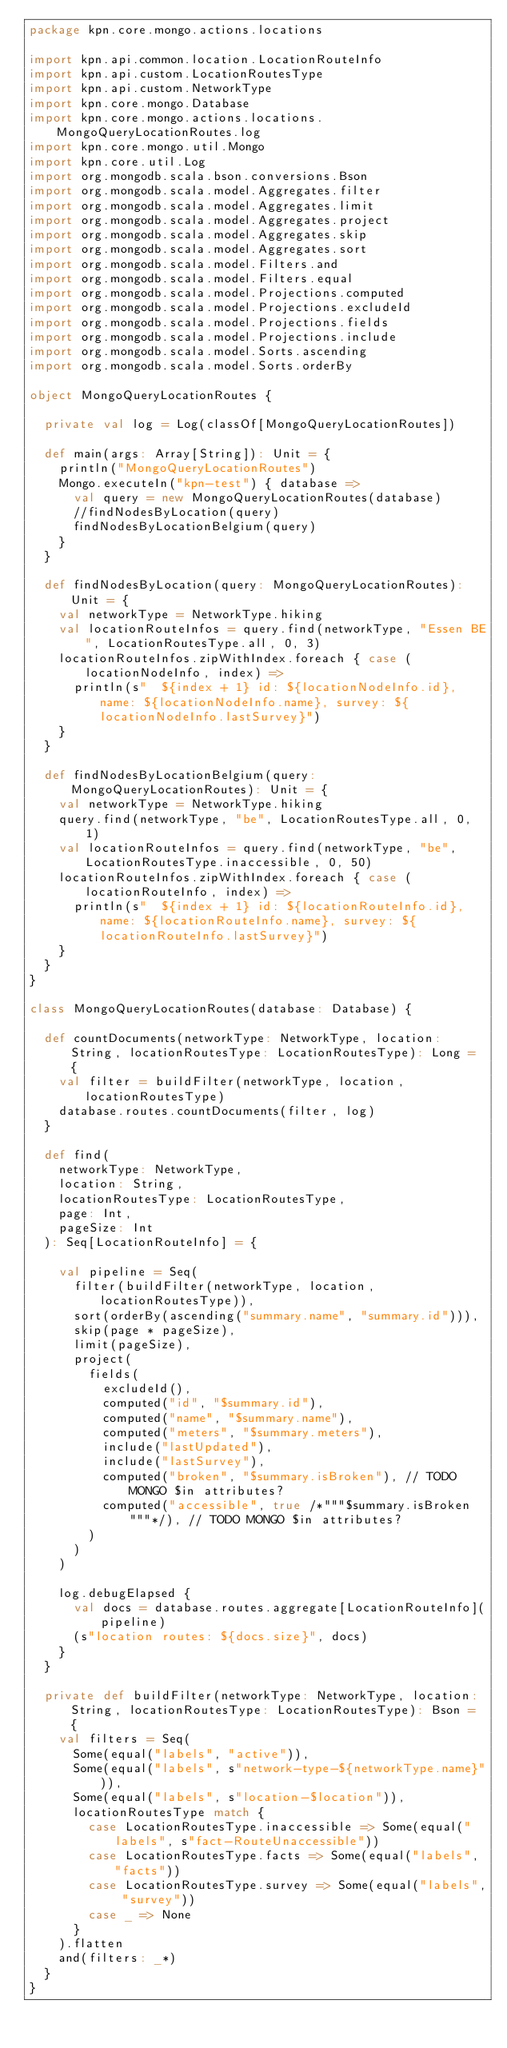Convert code to text. <code><loc_0><loc_0><loc_500><loc_500><_Scala_>package kpn.core.mongo.actions.locations

import kpn.api.common.location.LocationRouteInfo
import kpn.api.custom.LocationRoutesType
import kpn.api.custom.NetworkType
import kpn.core.mongo.Database
import kpn.core.mongo.actions.locations.MongoQueryLocationRoutes.log
import kpn.core.mongo.util.Mongo
import kpn.core.util.Log
import org.mongodb.scala.bson.conversions.Bson
import org.mongodb.scala.model.Aggregates.filter
import org.mongodb.scala.model.Aggregates.limit
import org.mongodb.scala.model.Aggregates.project
import org.mongodb.scala.model.Aggregates.skip
import org.mongodb.scala.model.Aggregates.sort
import org.mongodb.scala.model.Filters.and
import org.mongodb.scala.model.Filters.equal
import org.mongodb.scala.model.Projections.computed
import org.mongodb.scala.model.Projections.excludeId
import org.mongodb.scala.model.Projections.fields
import org.mongodb.scala.model.Projections.include
import org.mongodb.scala.model.Sorts.ascending
import org.mongodb.scala.model.Sorts.orderBy

object MongoQueryLocationRoutes {

  private val log = Log(classOf[MongoQueryLocationRoutes])

  def main(args: Array[String]): Unit = {
    println("MongoQueryLocationRoutes")
    Mongo.executeIn("kpn-test") { database =>
      val query = new MongoQueryLocationRoutes(database)
      //findNodesByLocation(query)
      findNodesByLocationBelgium(query)
    }
  }

  def findNodesByLocation(query: MongoQueryLocationRoutes): Unit = {
    val networkType = NetworkType.hiking
    val locationRouteInfos = query.find(networkType, "Essen BE", LocationRoutesType.all, 0, 3)
    locationRouteInfos.zipWithIndex.foreach { case (locationNodeInfo, index) =>
      println(s"  ${index + 1} id: ${locationNodeInfo.id}, name: ${locationNodeInfo.name}, survey: ${locationNodeInfo.lastSurvey}")
    }
  }

  def findNodesByLocationBelgium(query: MongoQueryLocationRoutes): Unit = {
    val networkType = NetworkType.hiking
    query.find(networkType, "be", LocationRoutesType.all, 0, 1)
    val locationRouteInfos = query.find(networkType, "be", LocationRoutesType.inaccessible, 0, 50)
    locationRouteInfos.zipWithIndex.foreach { case (locationRouteInfo, index) =>
      println(s"  ${index + 1} id: ${locationRouteInfo.id}, name: ${locationRouteInfo.name}, survey: ${locationRouteInfo.lastSurvey}")
    }
  }
}

class MongoQueryLocationRoutes(database: Database) {

  def countDocuments(networkType: NetworkType, location: String, locationRoutesType: LocationRoutesType): Long = {
    val filter = buildFilter(networkType, location, locationRoutesType)
    database.routes.countDocuments(filter, log)
  }

  def find(
    networkType: NetworkType,
    location: String,
    locationRoutesType: LocationRoutesType,
    page: Int,
    pageSize: Int
  ): Seq[LocationRouteInfo] = {

    val pipeline = Seq(
      filter(buildFilter(networkType, location, locationRoutesType)),
      sort(orderBy(ascending("summary.name", "summary.id"))),
      skip(page * pageSize),
      limit(pageSize),
      project(
        fields(
          excludeId(),
          computed("id", "$summary.id"),
          computed("name", "$summary.name"),
          computed("meters", "$summary.meters"),
          include("lastUpdated"),
          include("lastSurvey"),
          computed("broken", "$summary.isBroken"), // TODO MONGO $in attributes?
          computed("accessible", true /*"""$summary.isBroken"""*/), // TODO MONGO $in attributes?
        )
      )
    )

    log.debugElapsed {
      val docs = database.routes.aggregate[LocationRouteInfo](pipeline)
      (s"location routes: ${docs.size}", docs)
    }
  }

  private def buildFilter(networkType: NetworkType, location: String, locationRoutesType: LocationRoutesType): Bson = {
    val filters = Seq(
      Some(equal("labels", "active")),
      Some(equal("labels", s"network-type-${networkType.name}")),
      Some(equal("labels", s"location-$location")),
      locationRoutesType match {
        case LocationRoutesType.inaccessible => Some(equal("labels", s"fact-RouteUnaccessible"))
        case LocationRoutesType.facts => Some(equal("labels", "facts"))
        case LocationRoutesType.survey => Some(equal("labels", "survey"))
        case _ => None
      }
    ).flatten
    and(filters: _*)
  }
}
</code> 